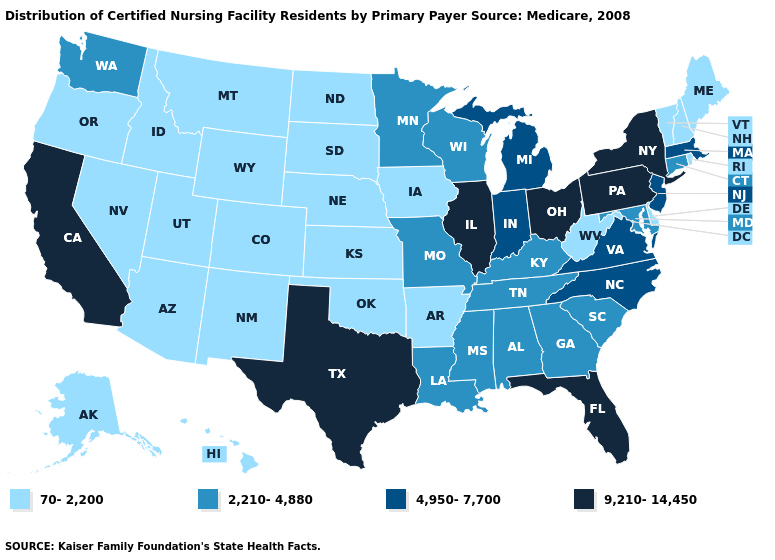Name the states that have a value in the range 70-2,200?
Answer briefly. Alaska, Arizona, Arkansas, Colorado, Delaware, Hawaii, Idaho, Iowa, Kansas, Maine, Montana, Nebraska, Nevada, New Hampshire, New Mexico, North Dakota, Oklahoma, Oregon, Rhode Island, South Dakota, Utah, Vermont, West Virginia, Wyoming. What is the highest value in the Northeast ?
Be succinct. 9,210-14,450. Name the states that have a value in the range 9,210-14,450?
Be succinct. California, Florida, Illinois, New York, Ohio, Pennsylvania, Texas. Does Alaska have a higher value than Arkansas?
Concise answer only. No. What is the lowest value in the South?
Give a very brief answer. 70-2,200. Name the states that have a value in the range 4,950-7,700?
Keep it brief. Indiana, Massachusetts, Michigan, New Jersey, North Carolina, Virginia. What is the highest value in the USA?
Short answer required. 9,210-14,450. Name the states that have a value in the range 9,210-14,450?
Write a very short answer. California, Florida, Illinois, New York, Ohio, Pennsylvania, Texas. Name the states that have a value in the range 2,210-4,880?
Be succinct. Alabama, Connecticut, Georgia, Kentucky, Louisiana, Maryland, Minnesota, Mississippi, Missouri, South Carolina, Tennessee, Washington, Wisconsin. Is the legend a continuous bar?
Write a very short answer. No. Name the states that have a value in the range 2,210-4,880?
Write a very short answer. Alabama, Connecticut, Georgia, Kentucky, Louisiana, Maryland, Minnesota, Mississippi, Missouri, South Carolina, Tennessee, Washington, Wisconsin. What is the highest value in states that border Oregon?
Quick response, please. 9,210-14,450. Does Arizona have the highest value in the West?
Answer briefly. No. Is the legend a continuous bar?
Be succinct. No. Among the states that border New Hampshire , which have the lowest value?
Write a very short answer. Maine, Vermont. 